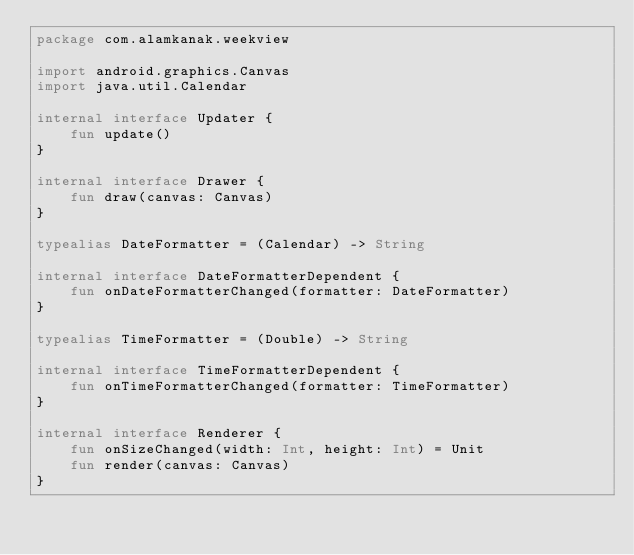Convert code to text. <code><loc_0><loc_0><loc_500><loc_500><_Kotlin_>package com.alamkanak.weekview

import android.graphics.Canvas
import java.util.Calendar

internal interface Updater {
    fun update()
}

internal interface Drawer {
    fun draw(canvas: Canvas)
}

typealias DateFormatter = (Calendar) -> String

internal interface DateFormatterDependent {
    fun onDateFormatterChanged(formatter: DateFormatter)
}

typealias TimeFormatter = (Double) -> String

internal interface TimeFormatterDependent {
    fun onTimeFormatterChanged(formatter: TimeFormatter)
}

internal interface Renderer {
    fun onSizeChanged(width: Int, height: Int) = Unit
    fun render(canvas: Canvas)
}
</code> 